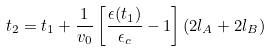Convert formula to latex. <formula><loc_0><loc_0><loc_500><loc_500>t _ { 2 } = t _ { 1 } + { \frac { 1 } { v _ { 0 } } } \left [ \frac { \epsilon ( t _ { 1 } ) } { \epsilon _ { c } } - 1 \right ] ( 2 l _ { A } + 2 l _ { B } )</formula> 